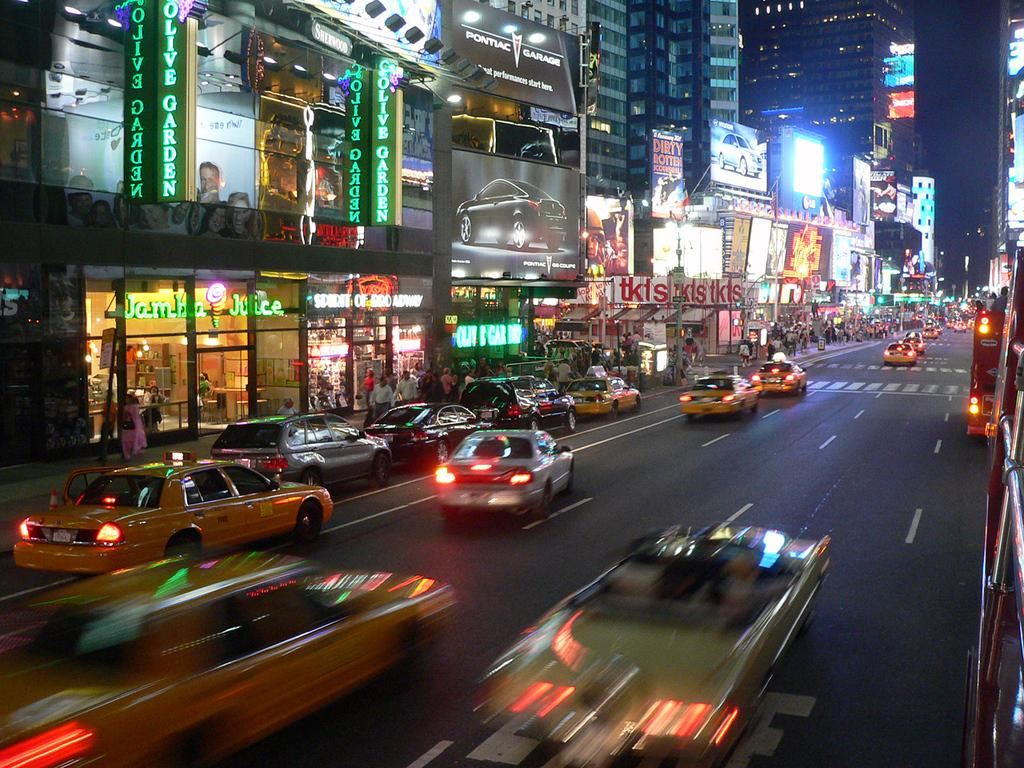<image>
Offer a succinct explanation of the picture presented. The Olive Garden is one of the restaurants on this busy street. 